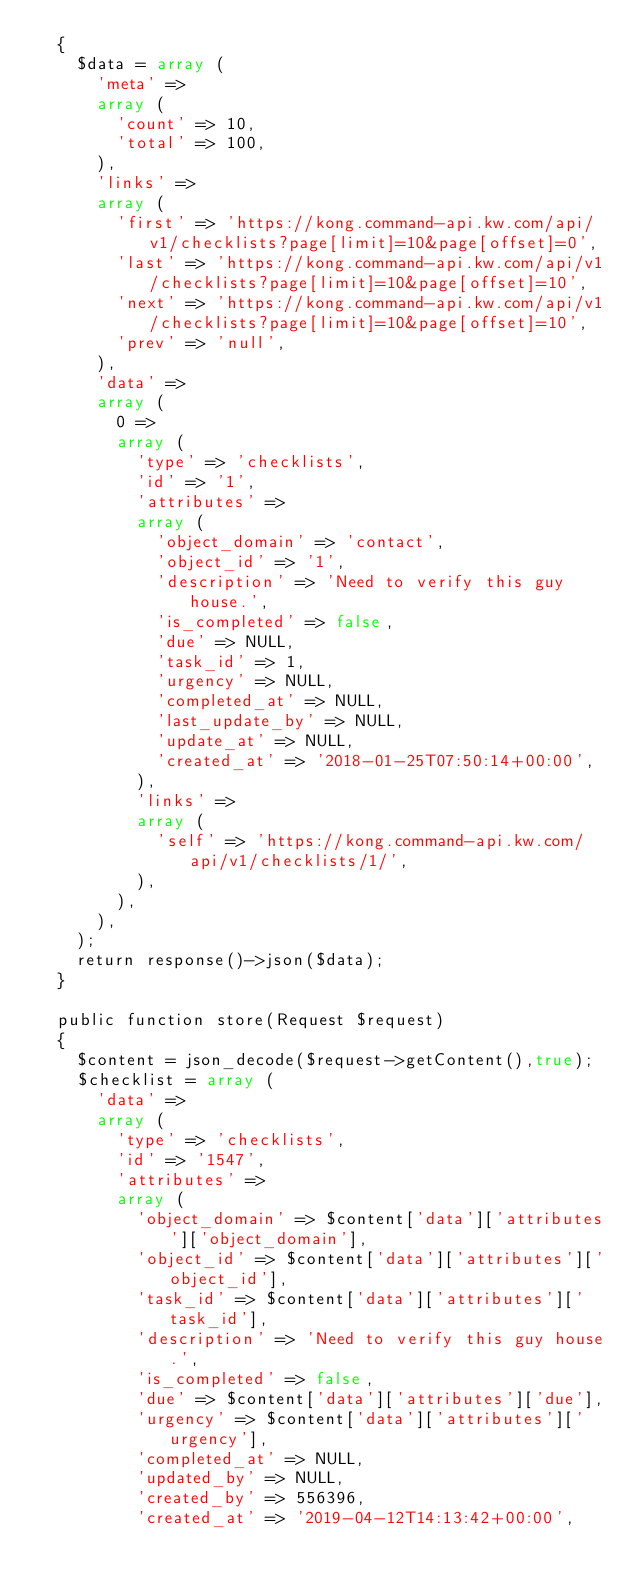<code> <loc_0><loc_0><loc_500><loc_500><_PHP_>  {
    $data = array (
      'meta' => 
      array (
        'count' => 10,
        'total' => 100,
      ),
      'links' => 
      array (
        'first' => 'https://kong.command-api.kw.com/api/v1/checklists?page[limit]=10&page[offset]=0',
        'last' => 'https://kong.command-api.kw.com/api/v1/checklists?page[limit]=10&page[offset]=10',
        'next' => 'https://kong.command-api.kw.com/api/v1/checklists?page[limit]=10&page[offset]=10',
        'prev' => 'null',
      ),
      'data' => 
      array (
        0 => 
        array (
          'type' => 'checklists',
          'id' => '1',
          'attributes' => 
          array (
            'object_domain' => 'contact',
            'object_id' => '1',
            'description' => 'Need to verify this guy house.',
            'is_completed' => false,
            'due' => NULL,
            'task_id' => 1,
            'urgency' => NULL,
            'completed_at' => NULL,
            'last_update_by' => NULL,
            'update_at' => NULL,
            'created_at' => '2018-01-25T07:50:14+00:00',
          ),
          'links' => 
          array (
            'self' => 'https://kong.command-api.kw.com/api/v1/checklists/1/',
          ),
        ),
      ),
    );
    return response()->json($data);
  }
  
  public function store(Request $request)
  {
    $content = json_decode($request->getContent(),true);
    $checklist = array (
      'data' => 
      array (
        'type' => 'checklists',
        'id' => '1547',
        'attributes' => 
        array (
          'object_domain' => $content['data']['attributes']['object_domain'],
          'object_id' => $content['data']['attributes']['object_id'],
          'task_id' => $content['data']['attributes']['task_id'],
          'description' => 'Need to verify this guy house.',
          'is_completed' => false,
          'due' => $content['data']['attributes']['due'],
          'urgency' => $content['data']['attributes']['urgency'],
          'completed_at' => NULL,
          'updated_by' => NULL,
          'created_by' => 556396,
          'created_at' => '2019-04-12T14:13:42+00:00',</code> 